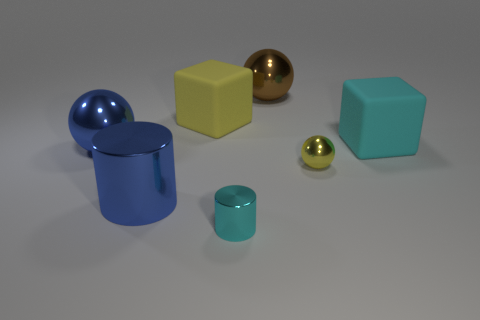What is the color of the object that is on the left side of the big blue object in front of the blue metallic ball in front of the large yellow block?
Your response must be concise. Blue. There is a large ball that is in front of the yellow matte cube; what is its color?
Offer a very short reply. Blue. What color is the other sphere that is the same size as the blue sphere?
Your answer should be very brief. Brown. Is the size of the brown thing the same as the cyan metal object?
Your response must be concise. No. How many big matte objects are left of the large blue cylinder?
Your answer should be very brief. 0. What number of objects are metal things behind the large blue metallic cylinder or brown shiny balls?
Your response must be concise. 3. Are there more brown things in front of the yellow matte thing than large spheres that are on the left side of the yellow ball?
Your answer should be very brief. No. The object that is the same color as the big shiny cylinder is what size?
Your response must be concise. Large. Does the cyan block have the same size as the cyan object in front of the large cyan rubber cube?
Give a very brief answer. No. How many cylinders are large brown shiny objects or blue shiny things?
Provide a short and direct response. 1. 